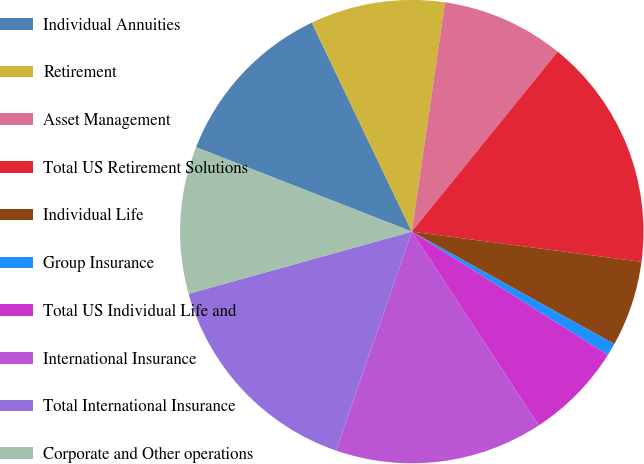Convert chart. <chart><loc_0><loc_0><loc_500><loc_500><pie_chart><fcel>Individual Annuities<fcel>Retirement<fcel>Asset Management<fcel>Total US Retirement Solutions<fcel>Individual Life<fcel>Group Insurance<fcel>Total US Individual Life and<fcel>International Insurance<fcel>Total International Insurance<fcel>Corporate and Other operations<nl><fcel>11.96%<fcel>9.4%<fcel>8.55%<fcel>16.24%<fcel>5.99%<fcel>0.86%<fcel>6.84%<fcel>14.53%<fcel>15.38%<fcel>10.26%<nl></chart> 